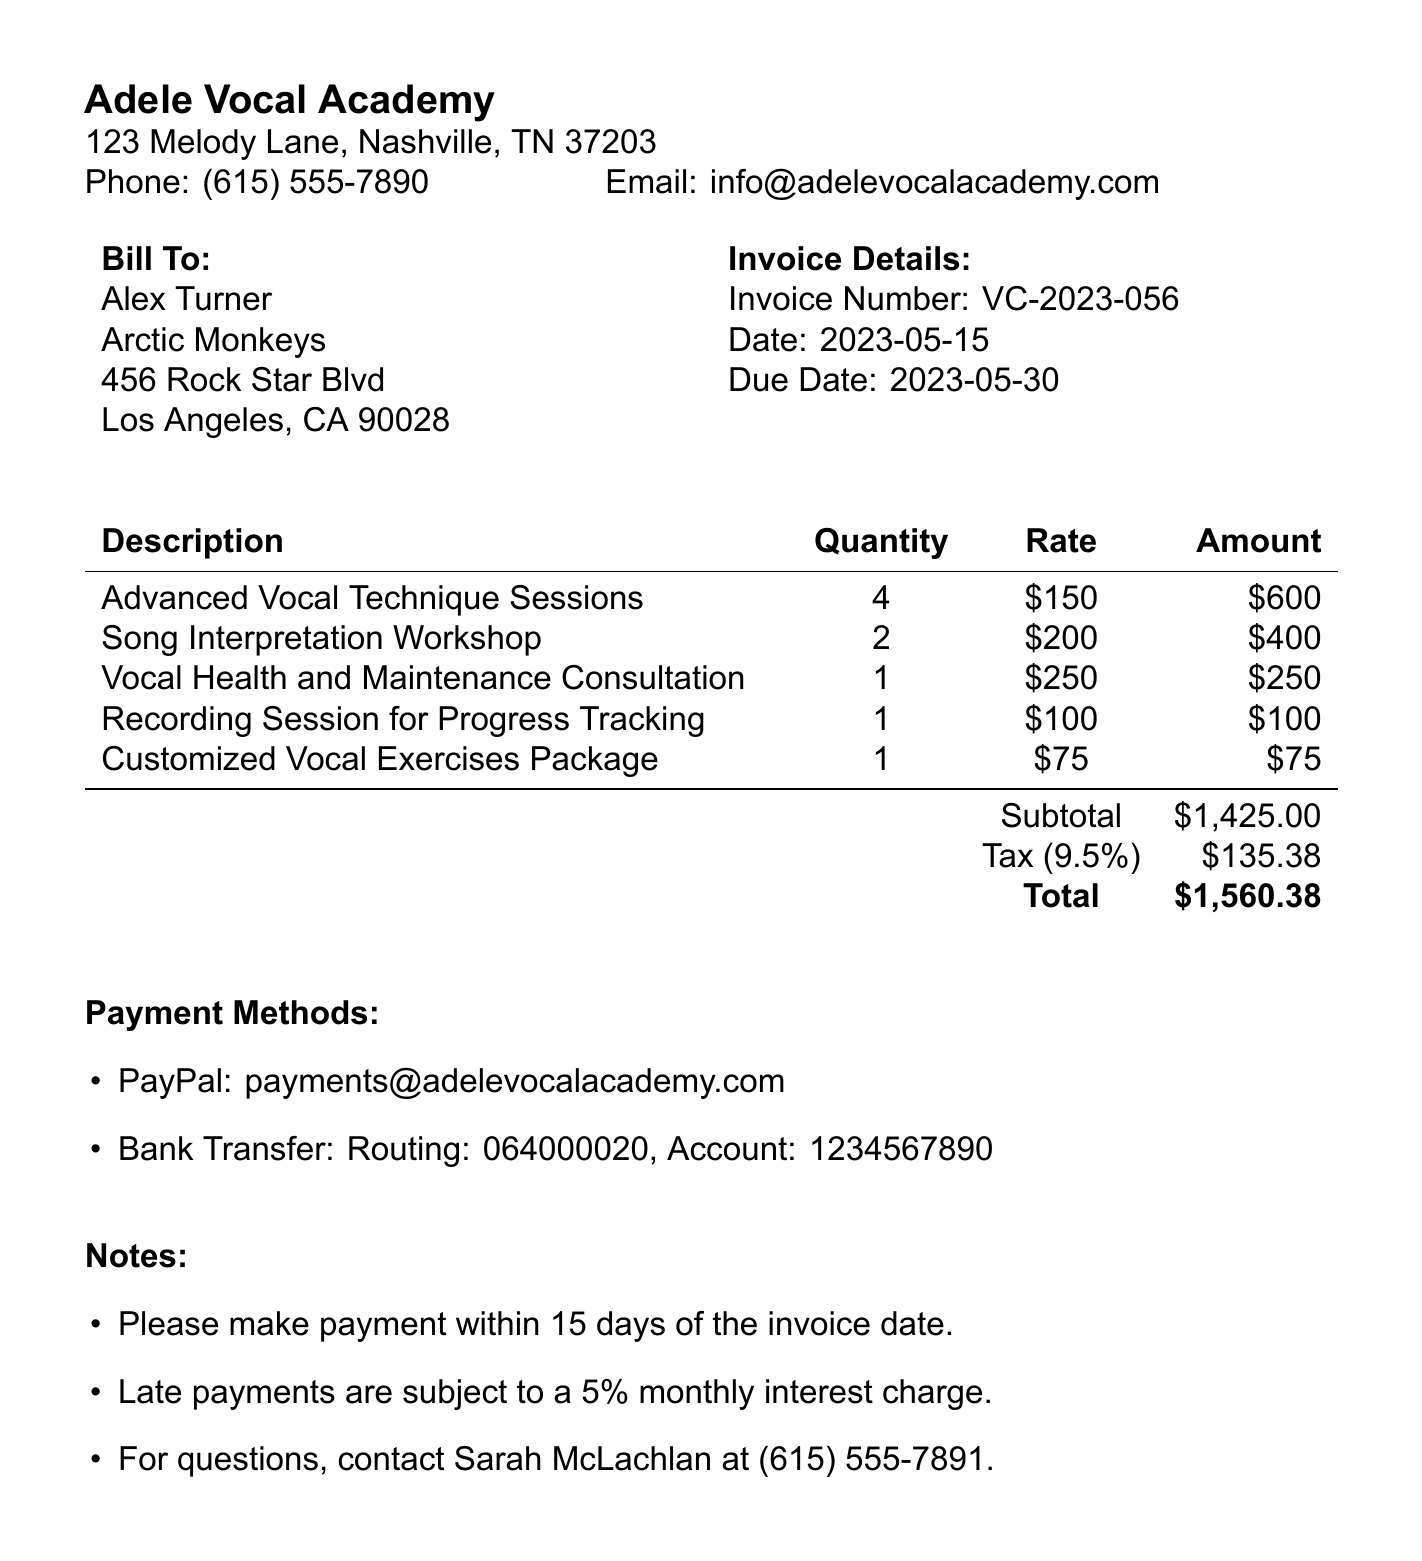What is the invoice number? The invoice number is explicitly mentioned in the document under invoice details.
Answer: VC-2023-056 When is the due date for payment? The due date is specified in the invoice details section of the document.
Answer: 2023-05-30 How many Advanced Vocal Technique Sessions were booked? This information is found in the services section of the invoice.
Answer: 4 What is the total amount due? The total amount due is calculated as the sum of the subtotal and the tax amount.
Answer: $1560.38 What is the contact number for Sarah McLachlan? This information is included in the notes section of the document.
Answer: (615) 555-7891 What is the tax rate applied on the invoice? The tax rate is clearly stated in the payment details section.
Answer: 9.5% How many Song Interpretation Workshops were provided? The number of workshops provided is mentioned in the services section of the invoice.
Answer: 2 What payment methods are accepted? The document lists specific payment methods under payment methods section.
Answer: PayPal and Bank Transfer 